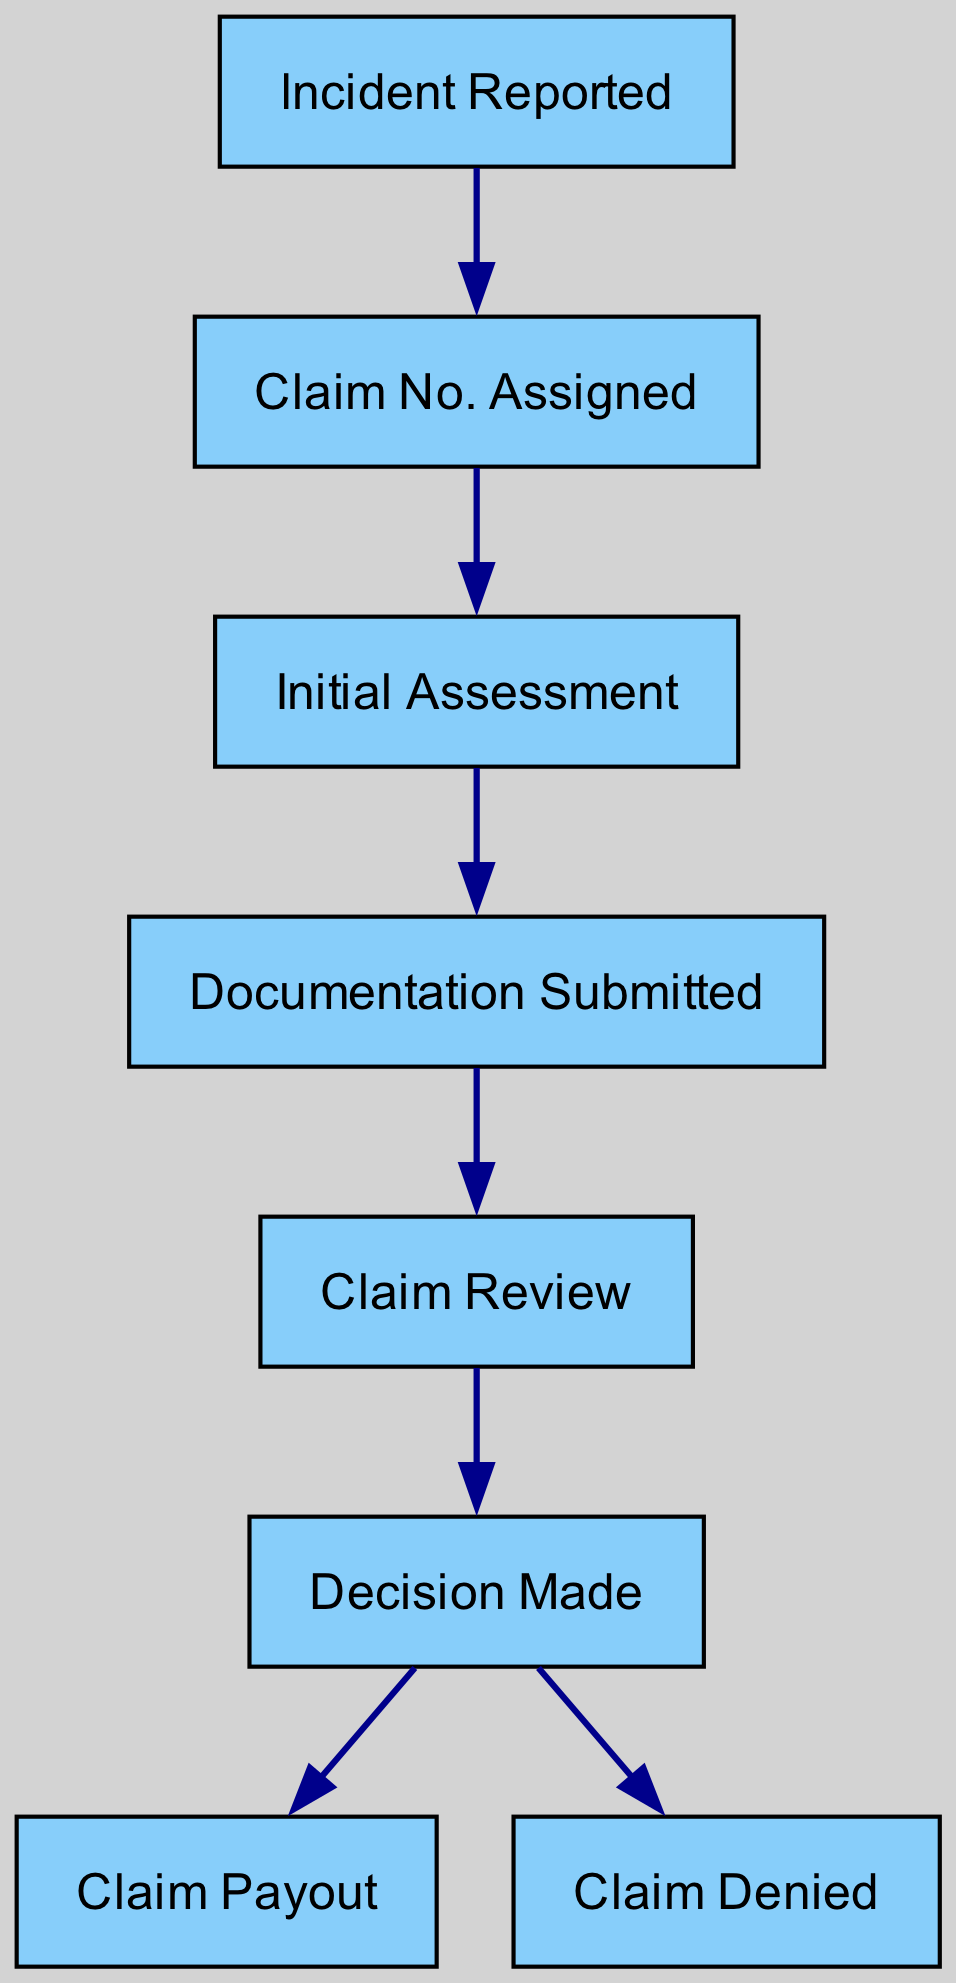What is the first step in the insurance claim process? The first step in the diagram is indicated by the node labeled "Incident Reported," which initiates the entire process flow.
Answer: Incident Reported How many edges are in the diagram? The diagram shows connections (edges) between nodes, and by counting them, there are a total of 6 edges connecting the various steps in the process flow.
Answer: 6 What happens after the claim review? Following the "Claim Review," the flow proceeds to "Decision Made," which is the next step in the process according to the diagram.
Answer: Decision Made If the decision is made, what are the possible outcomes? From the "Decision Made" node, there are two possible outcomes indicated by outgoing edges: one leads to "Claim Payout" and the other to "Claim Denied," representing the final results of the review.
Answer: Claim Payout, Claim Denied Which step involves submitting documentation? The step that involves submitting documentation is labeled "Documentation Submitted," which follows the initial assessment and is an essential part of the claim process.
Answer: Documentation Submitted What is the immediate step following "Claim No. Assigned"? After the "Claim No. Assigned," the next step indicated in the flow is "Initial Assessment," marking the progression in the claims process.
Answer: Initial Assessment What node represents a denied claim outcome? The node labeled "Claim Denied" directly represents the outcome where a claim is not approved, as shown in the final stages of the diagram.
Answer: Claim Denied How many outcomes are there after the "Decision Made"? There are two outcomes after the "Decision Made," which are "Claim Payout" and "Claim Denied," reflecting the resolution of the claim.
Answer: 2 What is the final step of the flow process in the diagram? The final step in the process flow is indicated by the nodes "Claim Payout" and "Claim Denied," as they are the end points where a claim is resolved either by payout or denial.
Answer: Claim Payout, Claim Denied 